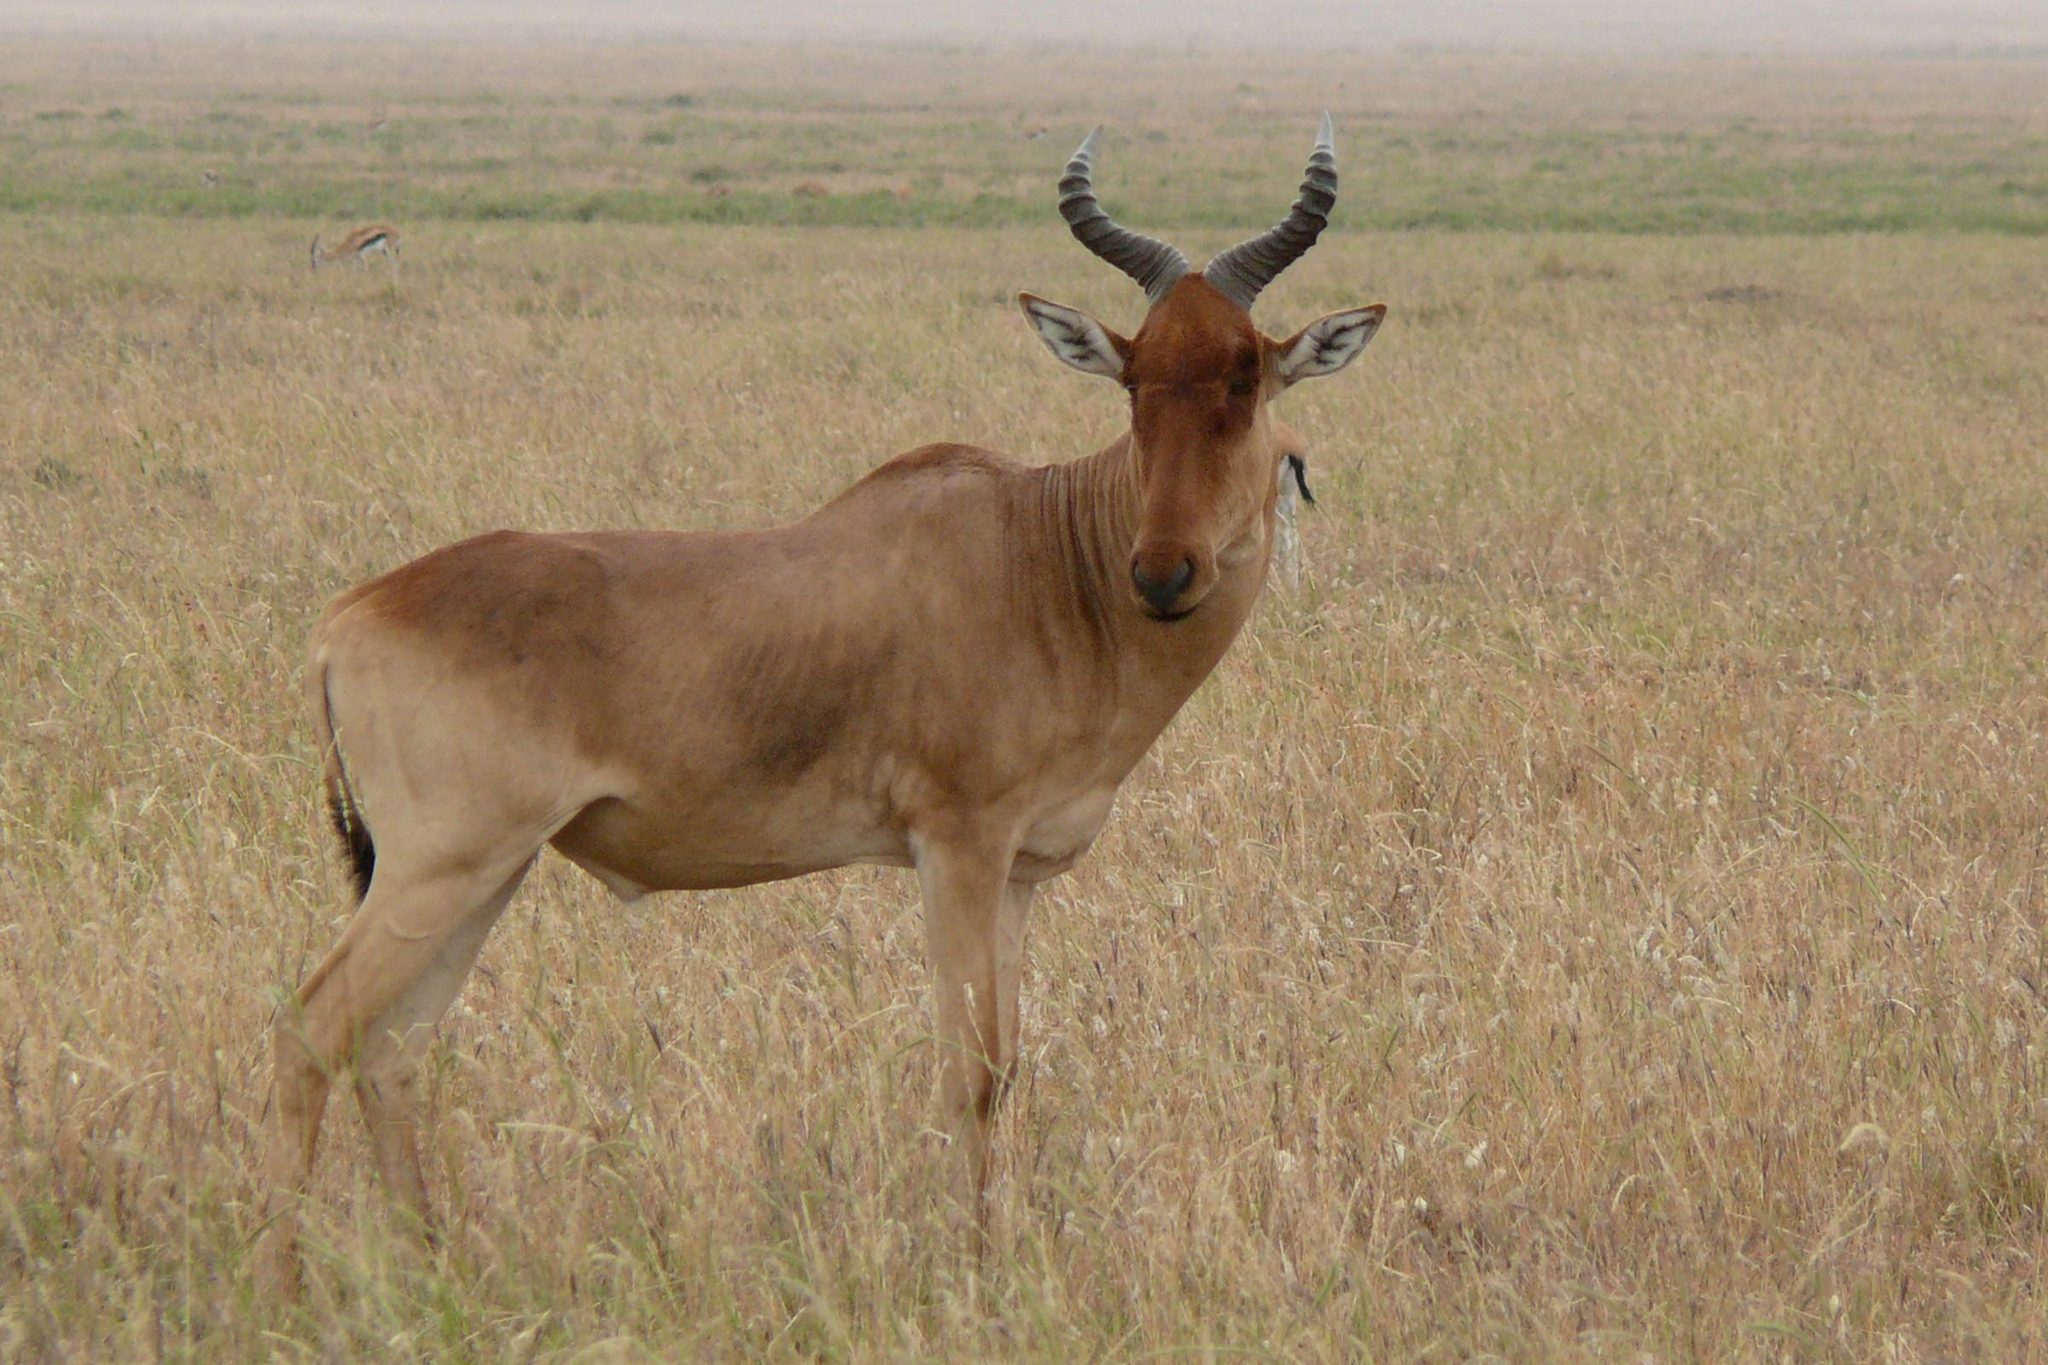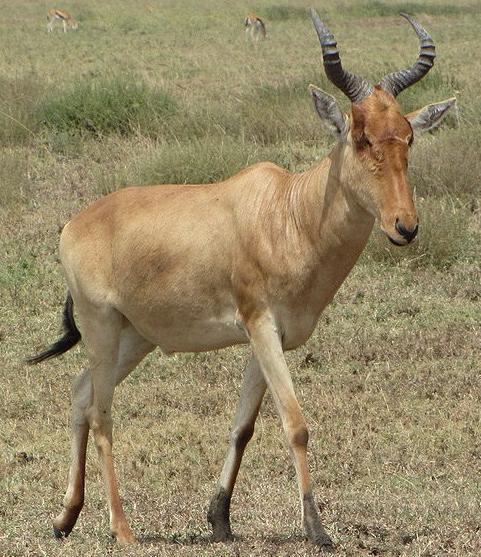The first image is the image on the left, the second image is the image on the right. For the images displayed, is the sentence "The left and right image contains the same number of elk walking right." factually correct? Answer yes or no. No. The first image is the image on the left, the second image is the image on the right. Given the left and right images, does the statement "The left image features one horned animal standing with its body aimed rightward and its head turned forward, and the right image features a horned animal standing with body and head aimed rightward." hold true? Answer yes or no. Yes. 